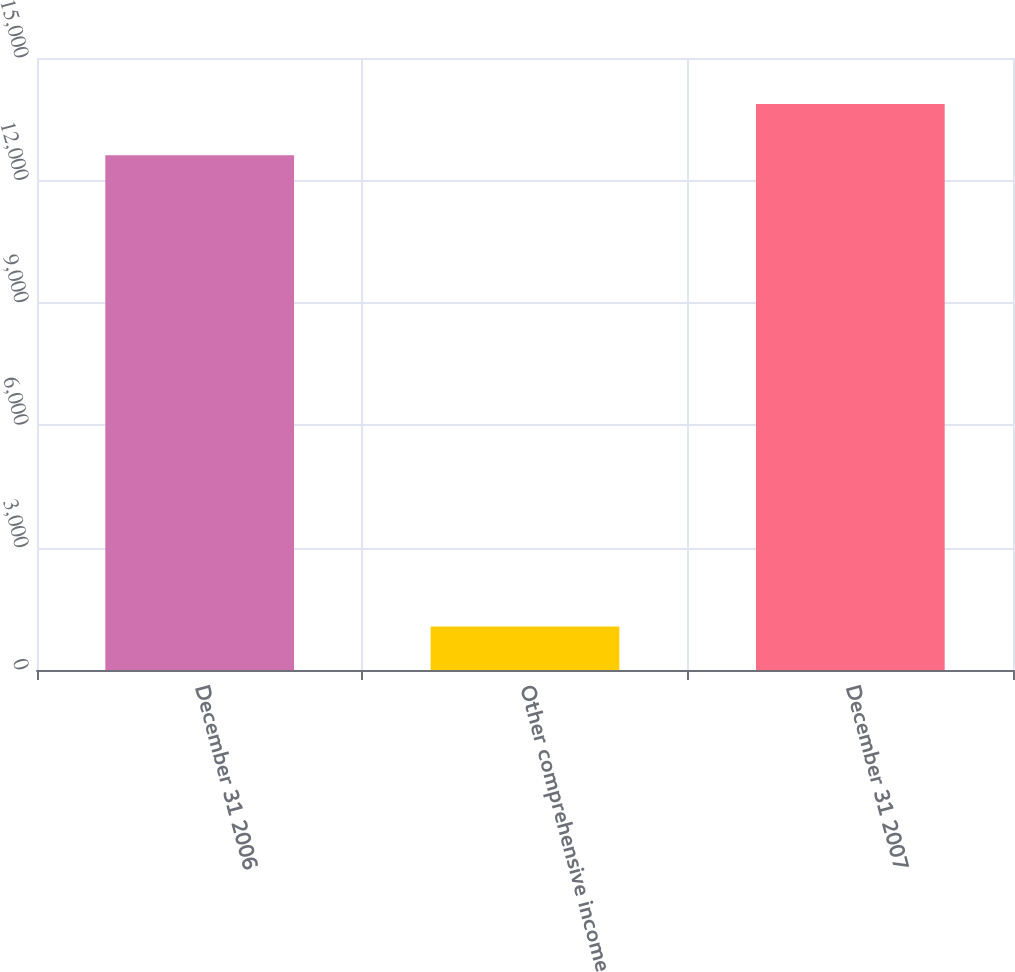<chart> <loc_0><loc_0><loc_500><loc_500><bar_chart><fcel>December 31 2006<fcel>Other comprehensive income<fcel>December 31 2007<nl><fcel>12614<fcel>1064<fcel>13875.4<nl></chart> 